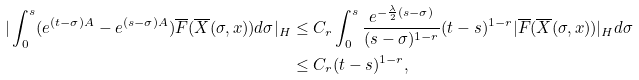<formula> <loc_0><loc_0><loc_500><loc_500>| \int _ { 0 } ^ { s } ( e ^ { ( t - \sigma ) A } - e ^ { ( s - \sigma ) A } ) \overline { F } ( \overline { X } ( \sigma , x ) ) d \sigma | _ { H } & \leq C _ { r } \int _ { 0 } ^ { s } \frac { e ^ { - \frac { \lambda } { 2 } ( s - \sigma ) } } { ( s - \sigma ) ^ { 1 - r } } ( t - s ) ^ { 1 - r } | \overline { F } ( \overline { X } ( \sigma , x ) ) | _ { H } d \sigma \\ & \leq C _ { r } ( t - s ) ^ { 1 - r } ,</formula> 